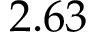<formula> <loc_0><loc_0><loc_500><loc_500>2 . 6 3</formula> 